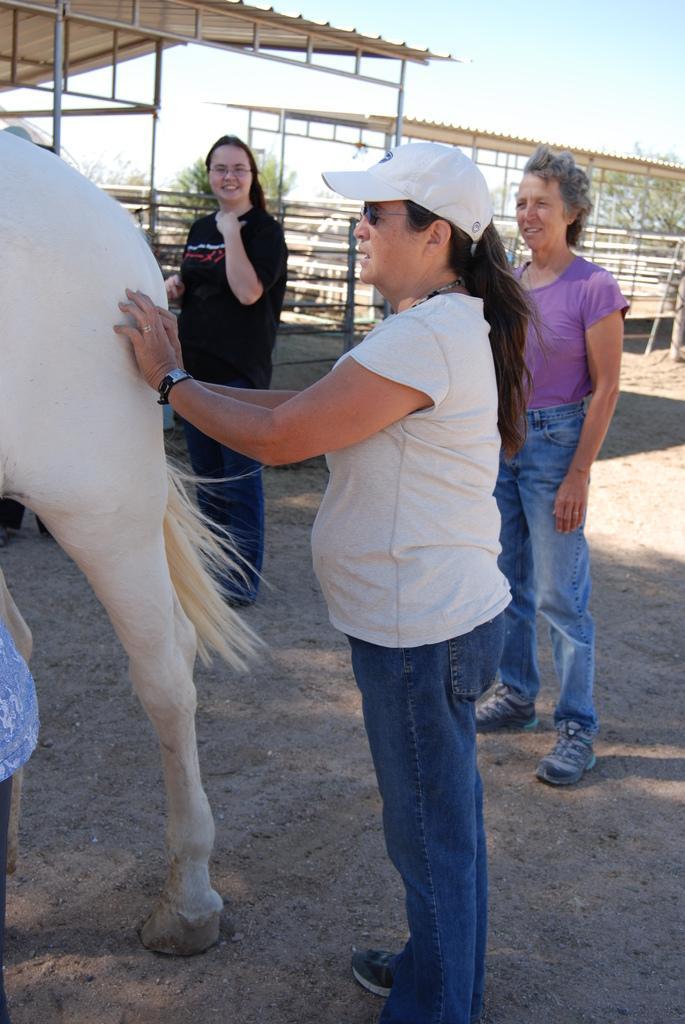Can you describe this image briefly? There are three women standing. One of the woman is wearing a white cap who is standing behind the horse. The horse is white in color. In the background there are some sheds and sky here. In the right side there are trees too. 